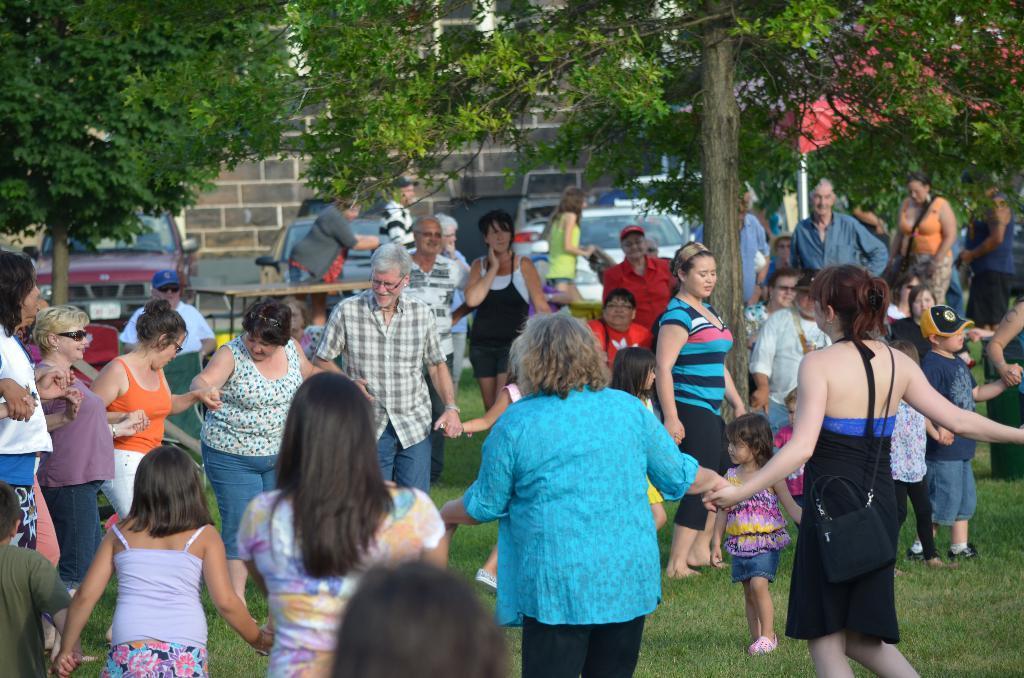Can you describe this image briefly? In the foreground of this picture, there is a crowd holding hands of each other standing on the grass. In the background, there are persons, table, cars, wall and the trees. 